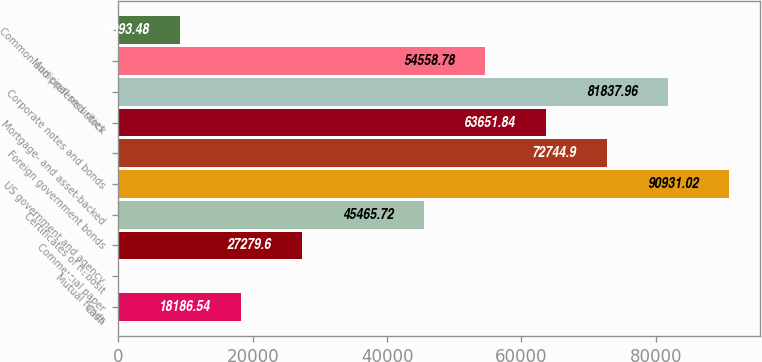Convert chart. <chart><loc_0><loc_0><loc_500><loc_500><bar_chart><fcel>Cash<fcel>Mutual funds<fcel>Commercial paper<fcel>Certificates of deposit<fcel>US government and agency<fcel>Foreign government bonds<fcel>Mortgage- and asset-backed<fcel>Corporate notes and bonds<fcel>Municipal securities<fcel>Common and preferred stock<nl><fcel>18186.5<fcel>0.42<fcel>27279.6<fcel>45465.7<fcel>90931<fcel>72744.9<fcel>63651.8<fcel>81838<fcel>54558.8<fcel>9093.48<nl></chart> 